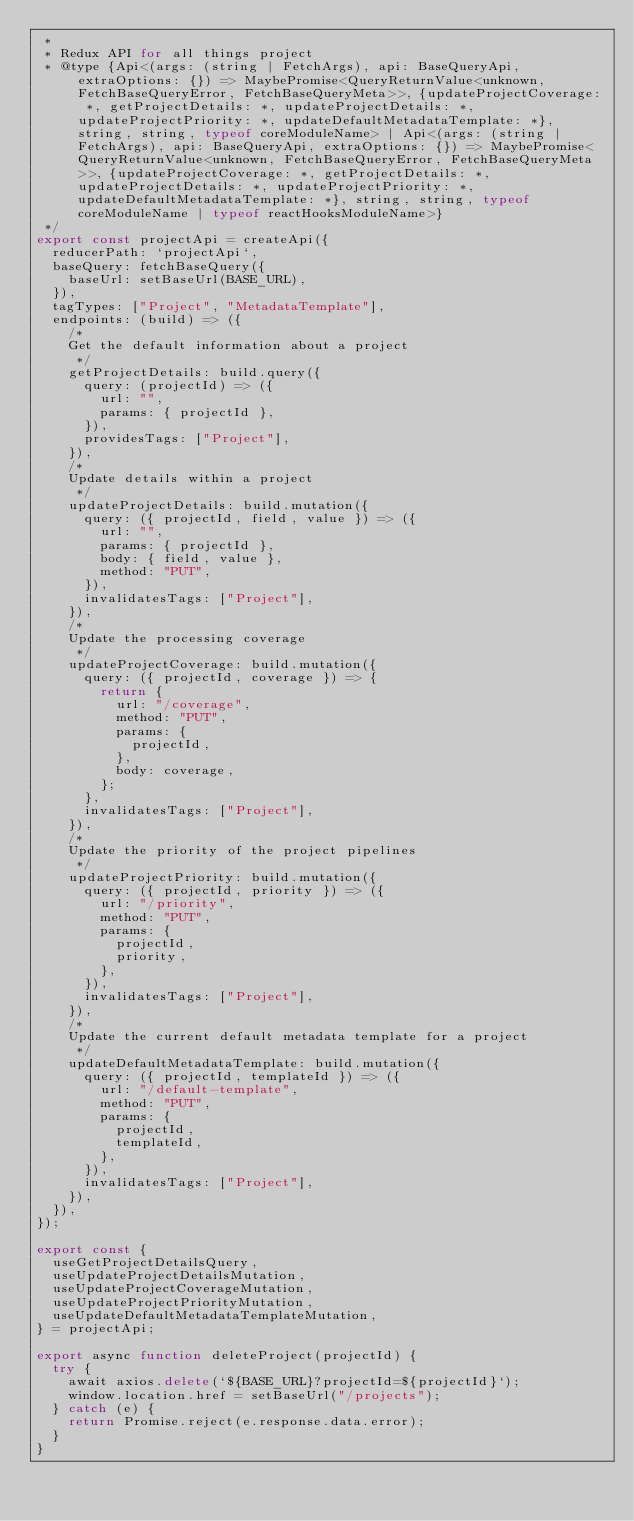Convert code to text. <code><loc_0><loc_0><loc_500><loc_500><_JavaScript_> *
 * Redux API for all things project
 * @type {Api<(args: (string | FetchArgs), api: BaseQueryApi, extraOptions: {}) => MaybePromise<QueryReturnValue<unknown, FetchBaseQueryError, FetchBaseQueryMeta>>, {updateProjectCoverage: *, getProjectDetails: *, updateProjectDetails: *, updateProjectPriority: *, updateDefaultMetadataTemplate: *}, string, string, typeof coreModuleName> | Api<(args: (string | FetchArgs), api: BaseQueryApi, extraOptions: {}) => MaybePromise<QueryReturnValue<unknown, FetchBaseQueryError, FetchBaseQueryMeta>>, {updateProjectCoverage: *, getProjectDetails: *, updateProjectDetails: *, updateProjectPriority: *, updateDefaultMetadataTemplate: *}, string, string, typeof coreModuleName | typeof reactHooksModuleName>}
 */
export const projectApi = createApi({
  reducerPath: `projectApi`,
  baseQuery: fetchBaseQuery({
    baseUrl: setBaseUrl(BASE_URL),
  }),
  tagTypes: ["Project", "MetadataTemplate"],
  endpoints: (build) => ({
    /*
    Get the default information about a project
     */
    getProjectDetails: build.query({
      query: (projectId) => ({
        url: "",
        params: { projectId },
      }),
      providesTags: ["Project"],
    }),
    /*
    Update details within a project
     */
    updateProjectDetails: build.mutation({
      query: ({ projectId, field, value }) => ({
        url: "",
        params: { projectId },
        body: { field, value },
        method: "PUT",
      }),
      invalidatesTags: ["Project"],
    }),
    /*
    Update the processing coverage
     */
    updateProjectCoverage: build.mutation({
      query: ({ projectId, coverage }) => {
        return {
          url: "/coverage",
          method: "PUT",
          params: {
            projectId,
          },
          body: coverage,
        };
      },
      invalidatesTags: ["Project"],
    }),
    /*
    Update the priority of the project pipelines
     */
    updateProjectPriority: build.mutation({
      query: ({ projectId, priority }) => ({
        url: "/priority",
        method: "PUT",
        params: {
          projectId,
          priority,
        },
      }),
      invalidatesTags: ["Project"],
    }),
    /*
    Update the current default metadata template for a project
     */
    updateDefaultMetadataTemplate: build.mutation({
      query: ({ projectId, templateId }) => ({
        url: "/default-template",
        method: "PUT",
        params: {
          projectId,
          templateId,
        },
      }),
      invalidatesTags: ["Project"],
    }),
  }),
});

export const {
  useGetProjectDetailsQuery,
  useUpdateProjectDetailsMutation,
  useUpdateProjectCoverageMutation,
  useUpdateProjectPriorityMutation,
  useUpdateDefaultMetadataTemplateMutation,
} = projectApi;

export async function deleteProject(projectId) {
  try {
    await axios.delete(`${BASE_URL}?projectId=${projectId}`);
    window.location.href = setBaseUrl("/projects");
  } catch (e) {
    return Promise.reject(e.response.data.error);
  }
}
</code> 